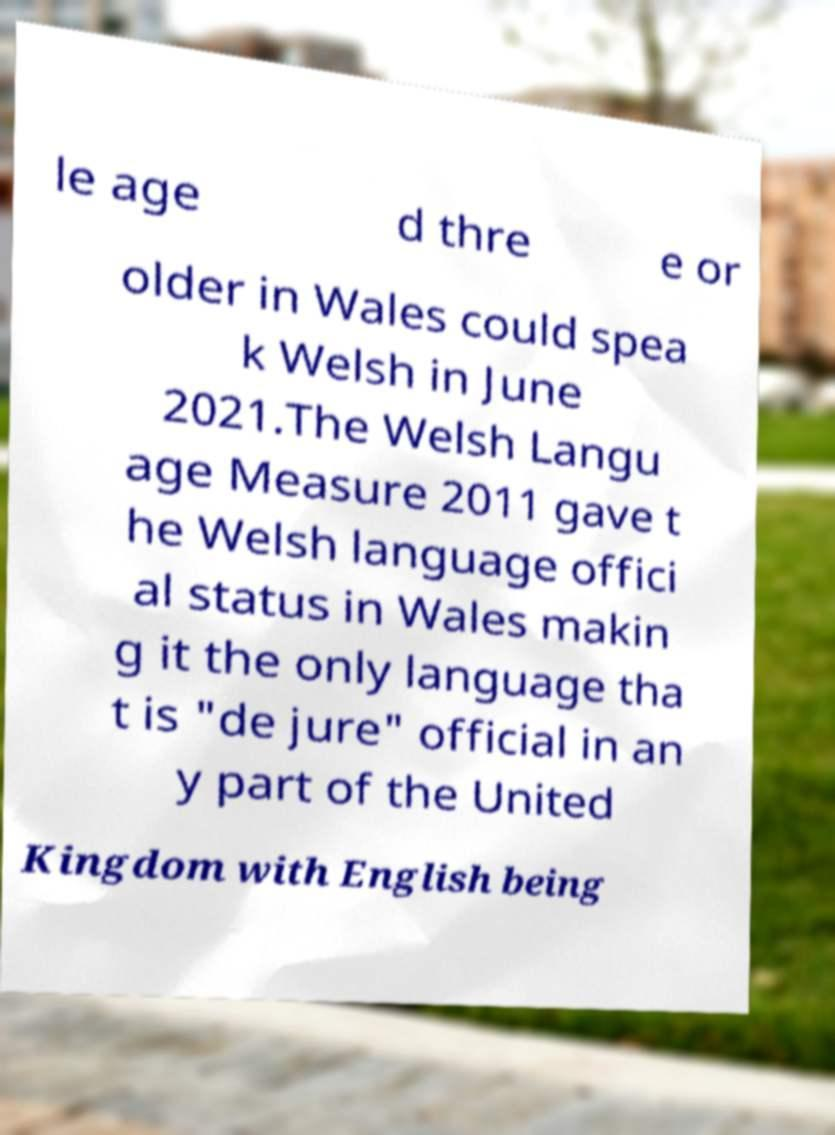Could you extract and type out the text from this image? le age d thre e or older in Wales could spea k Welsh in June 2021.The Welsh Langu age Measure 2011 gave t he Welsh language offici al status in Wales makin g it the only language tha t is "de jure" official in an y part of the United Kingdom with English being 